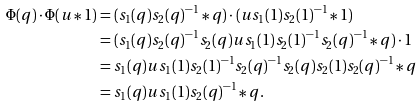Convert formula to latex. <formula><loc_0><loc_0><loc_500><loc_500>\Phi ( q ) \cdot \Phi ( u \ast 1 ) & = ( s _ { 1 } ( q ) s _ { 2 } ( q ) ^ { - 1 } \ast q ) \cdot ( u s _ { 1 } ( 1 ) s _ { 2 } ( 1 ) ^ { - 1 } \ast 1 ) \\ & = ( s _ { 1 } ( q ) s _ { 2 } ( q ) ^ { - 1 } s _ { 2 } ( q ) u s _ { 1 } ( 1 ) s _ { 2 } ( 1 ) ^ { - 1 } s _ { 2 } ( q ) ^ { - 1 } \ast q ) \cdot 1 \\ & = s _ { 1 } ( q ) u s _ { 1 } ( 1 ) s _ { 2 } ( 1 ) ^ { - 1 } s _ { 2 } ( q ) ^ { - 1 } s _ { 2 } ( q ) s _ { 2 } ( 1 ) s _ { 2 } ( q ) ^ { - 1 } \ast q \\ & = s _ { 1 } ( q ) u s _ { 1 } ( 1 ) s _ { 2 } ( q ) ^ { - 1 } \ast q .</formula> 